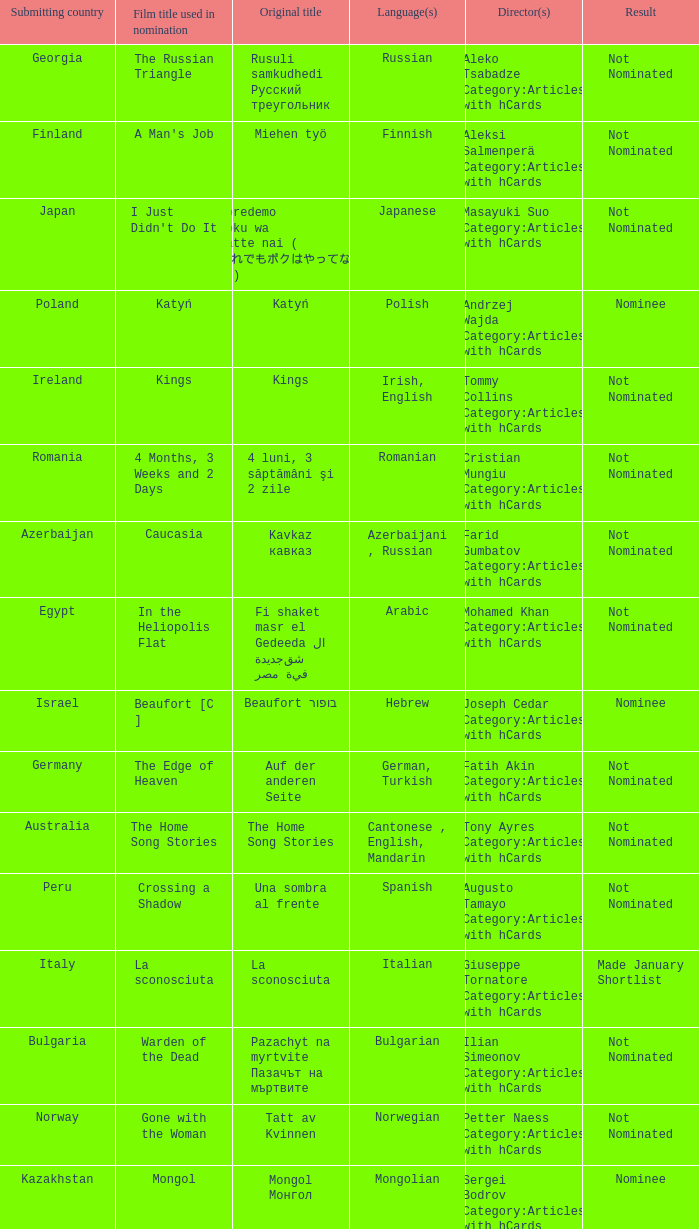What was the title of the movie from lebanon? Caramel. 